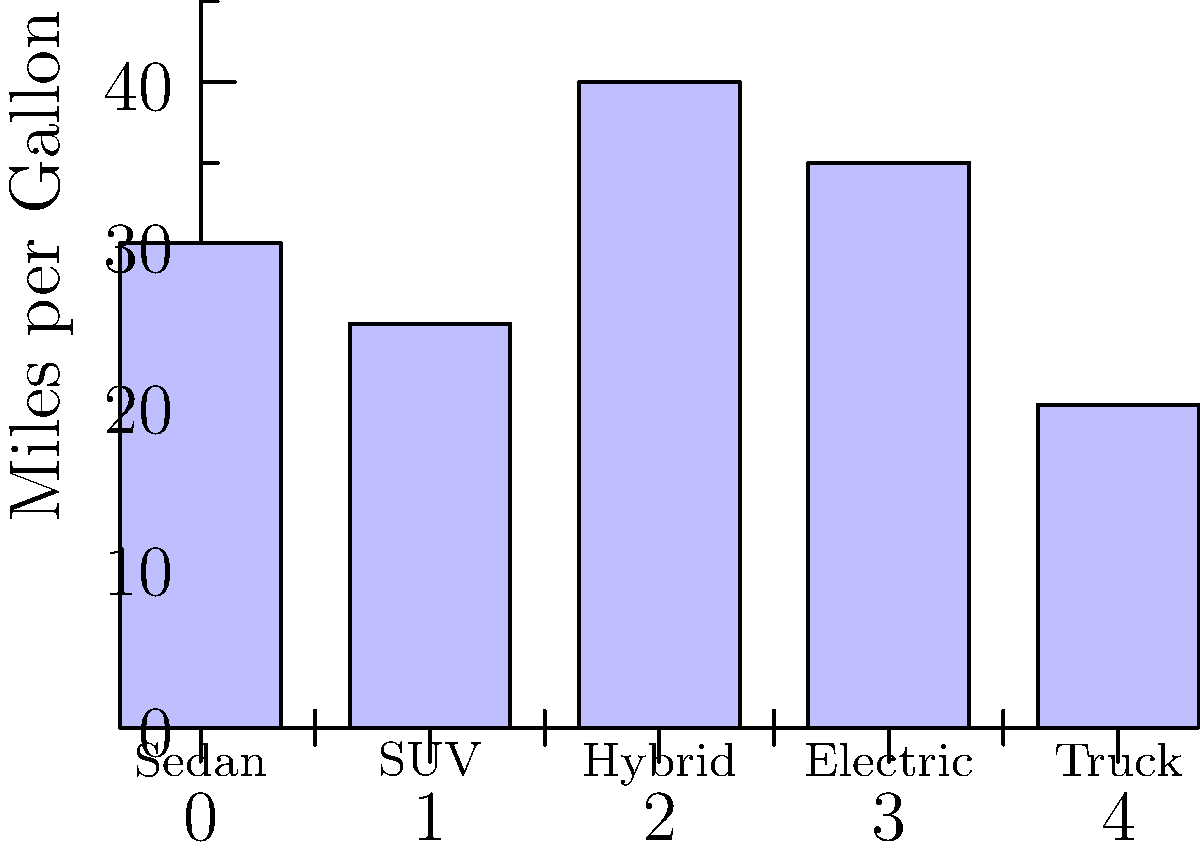The bar chart shows the average fuel efficiency (in miles per gallon) for different vehicle types. As a senior living alone in Sacramento, California, which vehicle type would be the most cost-effective for your daily commutes and occasional long-distance trips to visit family, considering both fuel efficiency and practicality? To determine the most cost-effective vehicle type, we need to consider both fuel efficiency and practicality for a senior living alone in Sacramento. Let's analyze the options step-by-step:

1. Sedan (30 mpg): Good fuel efficiency, comfortable for city driving and long trips.
2. SUV (25 mpg): Lower fuel efficiency, but offers more space and comfort.
3. Hybrid (40 mpg): Highest fuel efficiency, suitable for city driving and long trips.
4. Electric (35 mpg equivalent): High efficiency, but may have limited range for long trips.
5. Truck (20 mpg): Lowest fuel efficiency, impractical for daily use in a city.

For a senior living alone:
- Daily commutes in Sacramento: A fuel-efficient vehicle is ideal for city driving.
- Occasional long-distance trips: Needs a vehicle with good range and comfort.
- Practicality: Easy to enter/exit and maneuver in city traffic.

Considering these factors:
- Hybrid offers the best fuel efficiency (40 mpg) for both city and highway driving.
- It's suitable for daily commutes and long-distance trips.
- Hybrids are generally easy to drive and maintain, making them practical for seniors.
- The cost savings from high fuel efficiency will be beneficial in the long run.

Therefore, the hybrid vehicle would be the most cost-effective and practical choice for this scenario.
Answer: Hybrid 